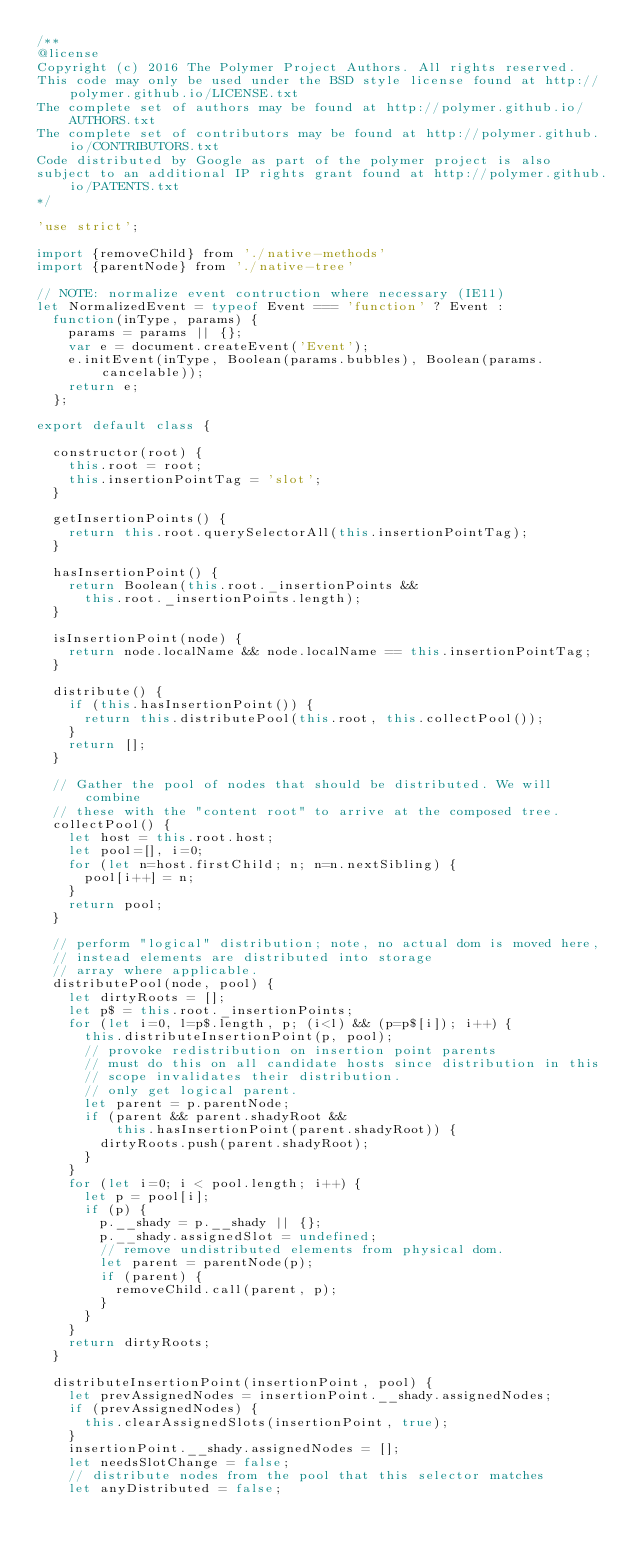Convert code to text. <code><loc_0><loc_0><loc_500><loc_500><_JavaScript_>/**
@license
Copyright (c) 2016 The Polymer Project Authors. All rights reserved.
This code may only be used under the BSD style license found at http://polymer.github.io/LICENSE.txt
The complete set of authors may be found at http://polymer.github.io/AUTHORS.txt
The complete set of contributors may be found at http://polymer.github.io/CONTRIBUTORS.txt
Code distributed by Google as part of the polymer project is also
subject to an additional IP rights grant found at http://polymer.github.io/PATENTS.txt
*/

'use strict';

import {removeChild} from './native-methods'
import {parentNode} from './native-tree'

// NOTE: normalize event contruction where necessary (IE11)
let NormalizedEvent = typeof Event === 'function' ? Event :
  function(inType, params) {
    params = params || {};
    var e = document.createEvent('Event');
    e.initEvent(inType, Boolean(params.bubbles), Boolean(params.cancelable));
    return e;
  };

export default class {

  constructor(root) {
    this.root = root;
    this.insertionPointTag = 'slot';
  }

  getInsertionPoints() {
    return this.root.querySelectorAll(this.insertionPointTag);
  }

  hasInsertionPoint() {
    return Boolean(this.root._insertionPoints &&
      this.root._insertionPoints.length);
  }

  isInsertionPoint(node) {
    return node.localName && node.localName == this.insertionPointTag;
  }

  distribute() {
    if (this.hasInsertionPoint()) {
      return this.distributePool(this.root, this.collectPool());
    }
    return [];
  }

  // Gather the pool of nodes that should be distributed. We will combine
  // these with the "content root" to arrive at the composed tree.
  collectPool() {
    let host = this.root.host;
    let pool=[], i=0;
    for (let n=host.firstChild; n; n=n.nextSibling) {
      pool[i++] = n;
    }
    return pool;
  }

  // perform "logical" distribution; note, no actual dom is moved here,
  // instead elements are distributed into storage
  // array where applicable.
  distributePool(node, pool) {
    let dirtyRoots = [];
    let p$ = this.root._insertionPoints;
    for (let i=0, l=p$.length, p; (i<l) && (p=p$[i]); i++) {
      this.distributeInsertionPoint(p, pool);
      // provoke redistribution on insertion point parents
      // must do this on all candidate hosts since distribution in this
      // scope invalidates their distribution.
      // only get logical parent.
      let parent = p.parentNode;
      if (parent && parent.shadyRoot &&
          this.hasInsertionPoint(parent.shadyRoot)) {
        dirtyRoots.push(parent.shadyRoot);
      }
    }
    for (let i=0; i < pool.length; i++) {
      let p = pool[i];
      if (p) {
        p.__shady = p.__shady || {};
        p.__shady.assignedSlot = undefined;
        // remove undistributed elements from physical dom.
        let parent = parentNode(p);
        if (parent) {
          removeChild.call(parent, p);
        }
      }
    }
    return dirtyRoots;
  }

  distributeInsertionPoint(insertionPoint, pool) {
    let prevAssignedNodes = insertionPoint.__shady.assignedNodes;
    if (prevAssignedNodes) {
      this.clearAssignedSlots(insertionPoint, true);
    }
    insertionPoint.__shady.assignedNodes = [];
    let needsSlotChange = false;
    // distribute nodes from the pool that this selector matches
    let anyDistributed = false;</code> 